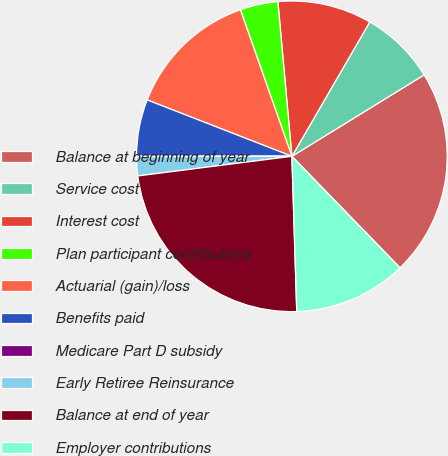Convert chart to OTSL. <chart><loc_0><loc_0><loc_500><loc_500><pie_chart><fcel>Balance at beginning of year<fcel>Service cost<fcel>Interest cost<fcel>Plan participant contributions<fcel>Actuarial (gain)/loss<fcel>Benefits paid<fcel>Medicare Part D subsidy<fcel>Early Retiree Reinsurance<fcel>Balance at end of year<fcel>Employer contributions<nl><fcel>21.53%<fcel>7.85%<fcel>9.8%<fcel>3.94%<fcel>13.71%<fcel>5.9%<fcel>0.04%<fcel>1.99%<fcel>23.48%<fcel>11.76%<nl></chart> 